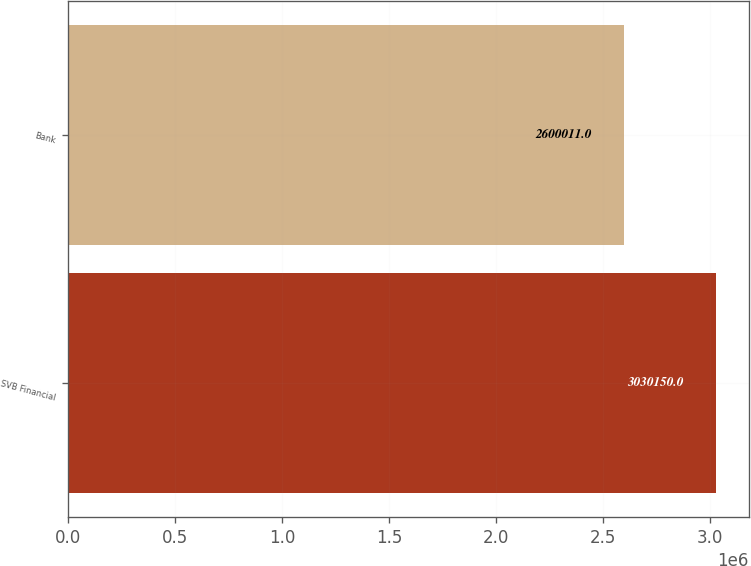Convert chart. <chart><loc_0><loc_0><loc_500><loc_500><bar_chart><fcel>SVB Financial<fcel>Bank<nl><fcel>3.03015e+06<fcel>2.60001e+06<nl></chart> 